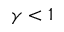Convert formula to latex. <formula><loc_0><loc_0><loc_500><loc_500>\gamma < 1</formula> 